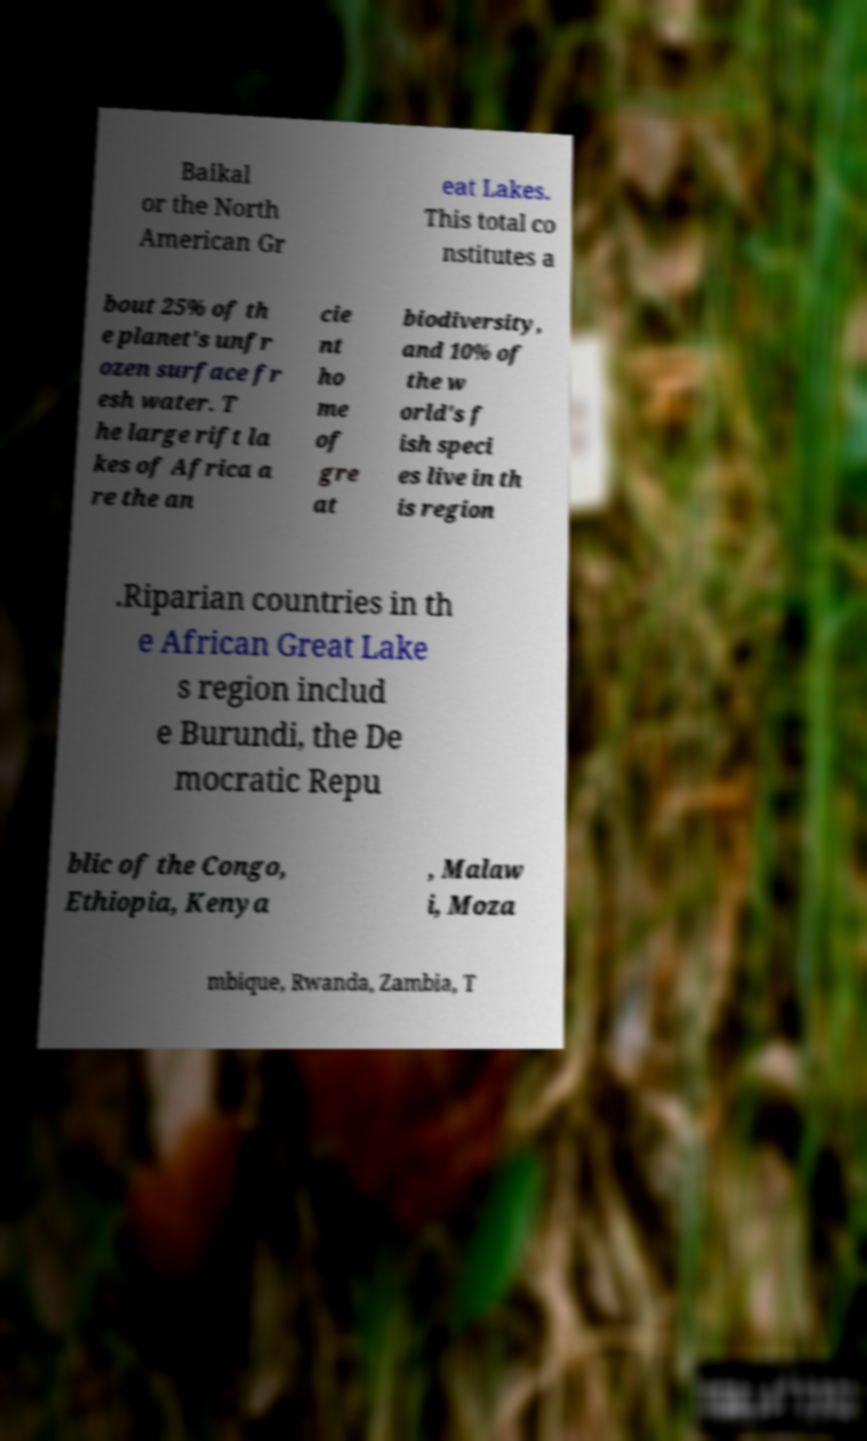Can you read and provide the text displayed in the image?This photo seems to have some interesting text. Can you extract and type it out for me? Baikal or the North American Gr eat Lakes. This total co nstitutes a bout 25% of th e planet's unfr ozen surface fr esh water. T he large rift la kes of Africa a re the an cie nt ho me of gre at biodiversity, and 10% of the w orld's f ish speci es live in th is region .Riparian countries in th e African Great Lake s region includ e Burundi, the De mocratic Repu blic of the Congo, Ethiopia, Kenya , Malaw i, Moza mbique, Rwanda, Zambia, T 